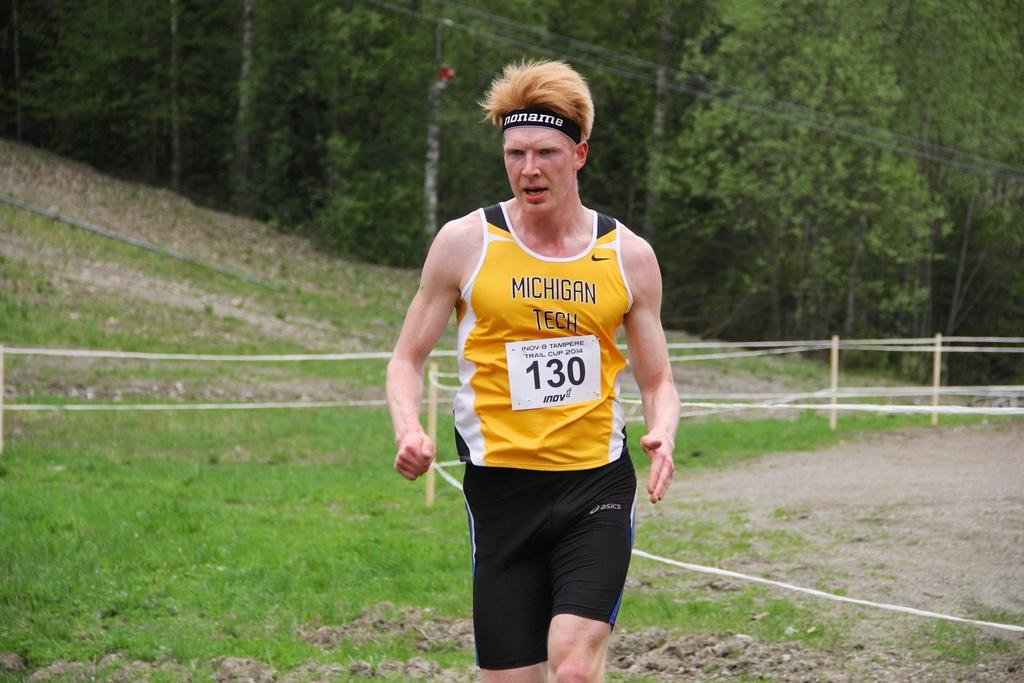<image>
Share a concise interpretation of the image provided. Michigan Tech runner 130 on grassy terrain near some trees. 